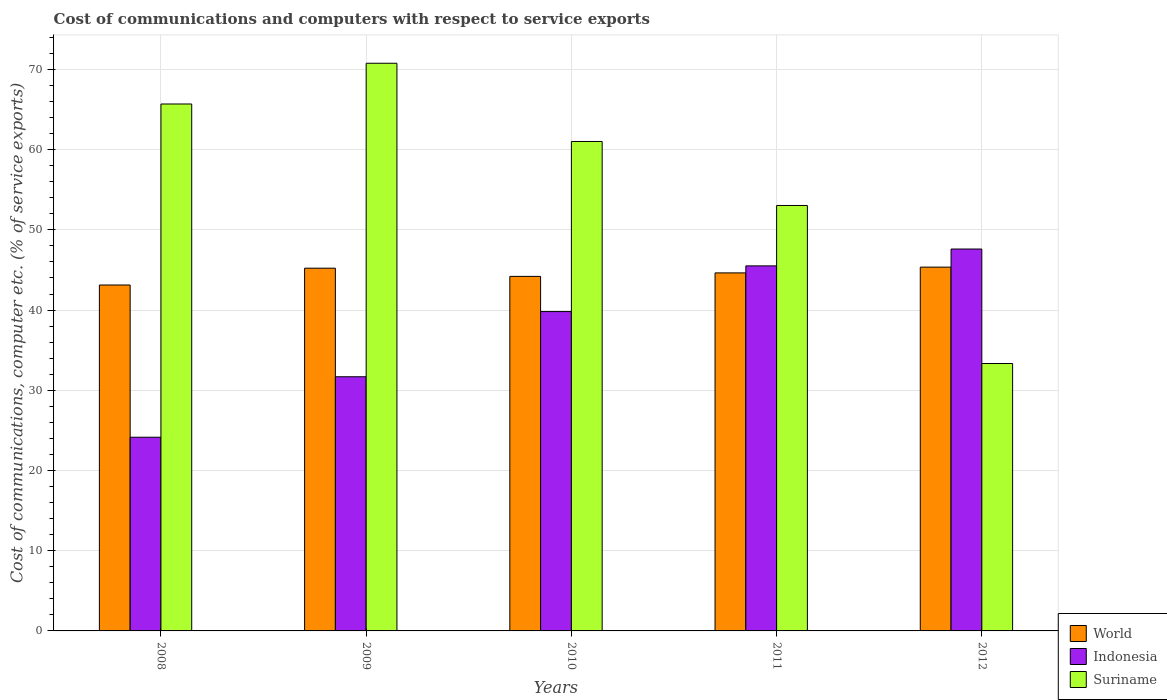Are the number of bars per tick equal to the number of legend labels?
Your response must be concise. Yes. How many bars are there on the 3rd tick from the left?
Offer a terse response. 3. In how many cases, is the number of bars for a given year not equal to the number of legend labels?
Make the answer very short. 0. What is the cost of communications and computers in World in 2010?
Offer a terse response. 44.2. Across all years, what is the maximum cost of communications and computers in Suriname?
Give a very brief answer. 70.77. Across all years, what is the minimum cost of communications and computers in Indonesia?
Give a very brief answer. 24.15. In which year was the cost of communications and computers in World maximum?
Make the answer very short. 2012. What is the total cost of communications and computers in World in the graph?
Your answer should be compact. 222.54. What is the difference between the cost of communications and computers in World in 2008 and that in 2011?
Provide a succinct answer. -1.51. What is the difference between the cost of communications and computers in Indonesia in 2008 and the cost of communications and computers in World in 2009?
Provide a succinct answer. -21.08. What is the average cost of communications and computers in Indonesia per year?
Offer a very short reply. 37.75. In the year 2011, what is the difference between the cost of communications and computers in Suriname and cost of communications and computers in World?
Give a very brief answer. 8.4. In how many years, is the cost of communications and computers in Suriname greater than 36 %?
Make the answer very short. 4. What is the ratio of the cost of communications and computers in Suriname in 2010 to that in 2011?
Keep it short and to the point. 1.15. Is the cost of communications and computers in Indonesia in 2008 less than that in 2010?
Keep it short and to the point. Yes. Is the difference between the cost of communications and computers in Suriname in 2008 and 2012 greater than the difference between the cost of communications and computers in World in 2008 and 2012?
Offer a terse response. Yes. What is the difference between the highest and the second highest cost of communications and computers in Indonesia?
Offer a very short reply. 2.1. What is the difference between the highest and the lowest cost of communications and computers in Indonesia?
Ensure brevity in your answer.  23.46. Is the sum of the cost of communications and computers in World in 2008 and 2011 greater than the maximum cost of communications and computers in Indonesia across all years?
Provide a short and direct response. Yes. What does the 1st bar from the left in 2009 represents?
Ensure brevity in your answer.  World. What does the 1st bar from the right in 2011 represents?
Your answer should be very brief. Suriname. How many years are there in the graph?
Offer a terse response. 5. Does the graph contain any zero values?
Provide a short and direct response. No. Does the graph contain grids?
Provide a short and direct response. Yes. How many legend labels are there?
Keep it short and to the point. 3. How are the legend labels stacked?
Offer a very short reply. Vertical. What is the title of the graph?
Make the answer very short. Cost of communications and computers with respect to service exports. Does "West Bank and Gaza" appear as one of the legend labels in the graph?
Provide a short and direct response. No. What is the label or title of the Y-axis?
Offer a very short reply. Cost of communications, computer etc. (% of service exports). What is the Cost of communications, computer etc. (% of service exports) of World in 2008?
Your response must be concise. 43.13. What is the Cost of communications, computer etc. (% of service exports) of Indonesia in 2008?
Provide a short and direct response. 24.15. What is the Cost of communications, computer etc. (% of service exports) in Suriname in 2008?
Provide a short and direct response. 65.69. What is the Cost of communications, computer etc. (% of service exports) in World in 2009?
Make the answer very short. 45.22. What is the Cost of communications, computer etc. (% of service exports) in Indonesia in 2009?
Your answer should be compact. 31.69. What is the Cost of communications, computer etc. (% of service exports) of Suriname in 2009?
Keep it short and to the point. 70.77. What is the Cost of communications, computer etc. (% of service exports) of World in 2010?
Offer a very short reply. 44.2. What is the Cost of communications, computer etc. (% of service exports) of Indonesia in 2010?
Keep it short and to the point. 39.81. What is the Cost of communications, computer etc. (% of service exports) in Suriname in 2010?
Make the answer very short. 61.02. What is the Cost of communications, computer etc. (% of service exports) in World in 2011?
Your answer should be compact. 44.64. What is the Cost of communications, computer etc. (% of service exports) in Indonesia in 2011?
Provide a short and direct response. 45.51. What is the Cost of communications, computer etc. (% of service exports) in Suriname in 2011?
Make the answer very short. 53.04. What is the Cost of communications, computer etc. (% of service exports) of World in 2012?
Your response must be concise. 45.35. What is the Cost of communications, computer etc. (% of service exports) of Indonesia in 2012?
Provide a short and direct response. 47.61. What is the Cost of communications, computer etc. (% of service exports) of Suriname in 2012?
Provide a succinct answer. 33.34. Across all years, what is the maximum Cost of communications, computer etc. (% of service exports) in World?
Your response must be concise. 45.35. Across all years, what is the maximum Cost of communications, computer etc. (% of service exports) of Indonesia?
Your response must be concise. 47.61. Across all years, what is the maximum Cost of communications, computer etc. (% of service exports) in Suriname?
Provide a succinct answer. 70.77. Across all years, what is the minimum Cost of communications, computer etc. (% of service exports) in World?
Offer a very short reply. 43.13. Across all years, what is the minimum Cost of communications, computer etc. (% of service exports) in Indonesia?
Your answer should be very brief. 24.15. Across all years, what is the minimum Cost of communications, computer etc. (% of service exports) of Suriname?
Make the answer very short. 33.34. What is the total Cost of communications, computer etc. (% of service exports) of World in the graph?
Offer a terse response. 222.54. What is the total Cost of communications, computer etc. (% of service exports) in Indonesia in the graph?
Provide a succinct answer. 188.77. What is the total Cost of communications, computer etc. (% of service exports) of Suriname in the graph?
Your answer should be compact. 283.86. What is the difference between the Cost of communications, computer etc. (% of service exports) in World in 2008 and that in 2009?
Your response must be concise. -2.1. What is the difference between the Cost of communications, computer etc. (% of service exports) in Indonesia in 2008 and that in 2009?
Your response must be concise. -7.54. What is the difference between the Cost of communications, computer etc. (% of service exports) of Suriname in 2008 and that in 2009?
Your response must be concise. -5.08. What is the difference between the Cost of communications, computer etc. (% of service exports) in World in 2008 and that in 2010?
Provide a succinct answer. -1.07. What is the difference between the Cost of communications, computer etc. (% of service exports) in Indonesia in 2008 and that in 2010?
Your answer should be compact. -15.67. What is the difference between the Cost of communications, computer etc. (% of service exports) of Suriname in 2008 and that in 2010?
Your answer should be compact. 4.67. What is the difference between the Cost of communications, computer etc. (% of service exports) of World in 2008 and that in 2011?
Your answer should be compact. -1.51. What is the difference between the Cost of communications, computer etc. (% of service exports) in Indonesia in 2008 and that in 2011?
Offer a very short reply. -21.36. What is the difference between the Cost of communications, computer etc. (% of service exports) in Suriname in 2008 and that in 2011?
Ensure brevity in your answer.  12.65. What is the difference between the Cost of communications, computer etc. (% of service exports) of World in 2008 and that in 2012?
Provide a succinct answer. -2.23. What is the difference between the Cost of communications, computer etc. (% of service exports) of Indonesia in 2008 and that in 2012?
Offer a terse response. -23.46. What is the difference between the Cost of communications, computer etc. (% of service exports) of Suriname in 2008 and that in 2012?
Offer a terse response. 32.36. What is the difference between the Cost of communications, computer etc. (% of service exports) of World in 2009 and that in 2010?
Your answer should be very brief. 1.02. What is the difference between the Cost of communications, computer etc. (% of service exports) in Indonesia in 2009 and that in 2010?
Your response must be concise. -8.13. What is the difference between the Cost of communications, computer etc. (% of service exports) of Suriname in 2009 and that in 2010?
Give a very brief answer. 9.75. What is the difference between the Cost of communications, computer etc. (% of service exports) of World in 2009 and that in 2011?
Provide a short and direct response. 0.59. What is the difference between the Cost of communications, computer etc. (% of service exports) of Indonesia in 2009 and that in 2011?
Your answer should be very brief. -13.82. What is the difference between the Cost of communications, computer etc. (% of service exports) in Suriname in 2009 and that in 2011?
Keep it short and to the point. 17.73. What is the difference between the Cost of communications, computer etc. (% of service exports) of World in 2009 and that in 2012?
Your response must be concise. -0.13. What is the difference between the Cost of communications, computer etc. (% of service exports) of Indonesia in 2009 and that in 2012?
Provide a short and direct response. -15.92. What is the difference between the Cost of communications, computer etc. (% of service exports) in Suriname in 2009 and that in 2012?
Offer a very short reply. 37.43. What is the difference between the Cost of communications, computer etc. (% of service exports) of World in 2010 and that in 2011?
Offer a terse response. -0.44. What is the difference between the Cost of communications, computer etc. (% of service exports) of Indonesia in 2010 and that in 2011?
Your answer should be compact. -5.69. What is the difference between the Cost of communications, computer etc. (% of service exports) of Suriname in 2010 and that in 2011?
Your response must be concise. 7.98. What is the difference between the Cost of communications, computer etc. (% of service exports) of World in 2010 and that in 2012?
Your answer should be compact. -1.15. What is the difference between the Cost of communications, computer etc. (% of service exports) in Indonesia in 2010 and that in 2012?
Give a very brief answer. -7.8. What is the difference between the Cost of communications, computer etc. (% of service exports) in Suriname in 2010 and that in 2012?
Give a very brief answer. 27.68. What is the difference between the Cost of communications, computer etc. (% of service exports) in World in 2011 and that in 2012?
Provide a short and direct response. -0.72. What is the difference between the Cost of communications, computer etc. (% of service exports) in Indonesia in 2011 and that in 2012?
Provide a short and direct response. -2.1. What is the difference between the Cost of communications, computer etc. (% of service exports) of Suriname in 2011 and that in 2012?
Your answer should be very brief. 19.7. What is the difference between the Cost of communications, computer etc. (% of service exports) in World in 2008 and the Cost of communications, computer etc. (% of service exports) in Indonesia in 2009?
Give a very brief answer. 11.44. What is the difference between the Cost of communications, computer etc. (% of service exports) in World in 2008 and the Cost of communications, computer etc. (% of service exports) in Suriname in 2009?
Offer a terse response. -27.64. What is the difference between the Cost of communications, computer etc. (% of service exports) of Indonesia in 2008 and the Cost of communications, computer etc. (% of service exports) of Suriname in 2009?
Offer a very short reply. -46.62. What is the difference between the Cost of communications, computer etc. (% of service exports) of World in 2008 and the Cost of communications, computer etc. (% of service exports) of Indonesia in 2010?
Offer a very short reply. 3.31. What is the difference between the Cost of communications, computer etc. (% of service exports) of World in 2008 and the Cost of communications, computer etc. (% of service exports) of Suriname in 2010?
Ensure brevity in your answer.  -17.89. What is the difference between the Cost of communications, computer etc. (% of service exports) of Indonesia in 2008 and the Cost of communications, computer etc. (% of service exports) of Suriname in 2010?
Your answer should be compact. -36.87. What is the difference between the Cost of communications, computer etc. (% of service exports) of World in 2008 and the Cost of communications, computer etc. (% of service exports) of Indonesia in 2011?
Ensure brevity in your answer.  -2.38. What is the difference between the Cost of communications, computer etc. (% of service exports) of World in 2008 and the Cost of communications, computer etc. (% of service exports) of Suriname in 2011?
Your answer should be compact. -9.91. What is the difference between the Cost of communications, computer etc. (% of service exports) in Indonesia in 2008 and the Cost of communications, computer etc. (% of service exports) in Suriname in 2011?
Provide a short and direct response. -28.89. What is the difference between the Cost of communications, computer etc. (% of service exports) of World in 2008 and the Cost of communications, computer etc. (% of service exports) of Indonesia in 2012?
Offer a very short reply. -4.49. What is the difference between the Cost of communications, computer etc. (% of service exports) in World in 2008 and the Cost of communications, computer etc. (% of service exports) in Suriname in 2012?
Your response must be concise. 9.79. What is the difference between the Cost of communications, computer etc. (% of service exports) of Indonesia in 2008 and the Cost of communications, computer etc. (% of service exports) of Suriname in 2012?
Ensure brevity in your answer.  -9.19. What is the difference between the Cost of communications, computer etc. (% of service exports) in World in 2009 and the Cost of communications, computer etc. (% of service exports) in Indonesia in 2010?
Your answer should be compact. 5.41. What is the difference between the Cost of communications, computer etc. (% of service exports) in World in 2009 and the Cost of communications, computer etc. (% of service exports) in Suriname in 2010?
Ensure brevity in your answer.  -15.8. What is the difference between the Cost of communications, computer etc. (% of service exports) of Indonesia in 2009 and the Cost of communications, computer etc. (% of service exports) of Suriname in 2010?
Give a very brief answer. -29.33. What is the difference between the Cost of communications, computer etc. (% of service exports) in World in 2009 and the Cost of communications, computer etc. (% of service exports) in Indonesia in 2011?
Your answer should be compact. -0.29. What is the difference between the Cost of communications, computer etc. (% of service exports) of World in 2009 and the Cost of communications, computer etc. (% of service exports) of Suriname in 2011?
Your answer should be very brief. -7.82. What is the difference between the Cost of communications, computer etc. (% of service exports) of Indonesia in 2009 and the Cost of communications, computer etc. (% of service exports) of Suriname in 2011?
Give a very brief answer. -21.35. What is the difference between the Cost of communications, computer etc. (% of service exports) in World in 2009 and the Cost of communications, computer etc. (% of service exports) in Indonesia in 2012?
Offer a terse response. -2.39. What is the difference between the Cost of communications, computer etc. (% of service exports) in World in 2009 and the Cost of communications, computer etc. (% of service exports) in Suriname in 2012?
Provide a succinct answer. 11.88. What is the difference between the Cost of communications, computer etc. (% of service exports) in Indonesia in 2009 and the Cost of communications, computer etc. (% of service exports) in Suriname in 2012?
Make the answer very short. -1.65. What is the difference between the Cost of communications, computer etc. (% of service exports) of World in 2010 and the Cost of communications, computer etc. (% of service exports) of Indonesia in 2011?
Your response must be concise. -1.31. What is the difference between the Cost of communications, computer etc. (% of service exports) of World in 2010 and the Cost of communications, computer etc. (% of service exports) of Suriname in 2011?
Provide a short and direct response. -8.84. What is the difference between the Cost of communications, computer etc. (% of service exports) of Indonesia in 2010 and the Cost of communications, computer etc. (% of service exports) of Suriname in 2011?
Ensure brevity in your answer.  -13.23. What is the difference between the Cost of communications, computer etc. (% of service exports) of World in 2010 and the Cost of communications, computer etc. (% of service exports) of Indonesia in 2012?
Provide a short and direct response. -3.41. What is the difference between the Cost of communications, computer etc. (% of service exports) of World in 2010 and the Cost of communications, computer etc. (% of service exports) of Suriname in 2012?
Provide a short and direct response. 10.86. What is the difference between the Cost of communications, computer etc. (% of service exports) in Indonesia in 2010 and the Cost of communications, computer etc. (% of service exports) in Suriname in 2012?
Offer a very short reply. 6.48. What is the difference between the Cost of communications, computer etc. (% of service exports) in World in 2011 and the Cost of communications, computer etc. (% of service exports) in Indonesia in 2012?
Ensure brevity in your answer.  -2.98. What is the difference between the Cost of communications, computer etc. (% of service exports) in World in 2011 and the Cost of communications, computer etc. (% of service exports) in Suriname in 2012?
Make the answer very short. 11.3. What is the difference between the Cost of communications, computer etc. (% of service exports) in Indonesia in 2011 and the Cost of communications, computer etc. (% of service exports) in Suriname in 2012?
Ensure brevity in your answer.  12.17. What is the average Cost of communications, computer etc. (% of service exports) in World per year?
Offer a very short reply. 44.51. What is the average Cost of communications, computer etc. (% of service exports) in Indonesia per year?
Keep it short and to the point. 37.75. What is the average Cost of communications, computer etc. (% of service exports) of Suriname per year?
Your answer should be compact. 56.77. In the year 2008, what is the difference between the Cost of communications, computer etc. (% of service exports) of World and Cost of communications, computer etc. (% of service exports) of Indonesia?
Your answer should be compact. 18.98. In the year 2008, what is the difference between the Cost of communications, computer etc. (% of service exports) of World and Cost of communications, computer etc. (% of service exports) of Suriname?
Provide a succinct answer. -22.57. In the year 2008, what is the difference between the Cost of communications, computer etc. (% of service exports) in Indonesia and Cost of communications, computer etc. (% of service exports) in Suriname?
Your response must be concise. -41.55. In the year 2009, what is the difference between the Cost of communications, computer etc. (% of service exports) in World and Cost of communications, computer etc. (% of service exports) in Indonesia?
Ensure brevity in your answer.  13.54. In the year 2009, what is the difference between the Cost of communications, computer etc. (% of service exports) of World and Cost of communications, computer etc. (% of service exports) of Suriname?
Your answer should be compact. -25.55. In the year 2009, what is the difference between the Cost of communications, computer etc. (% of service exports) in Indonesia and Cost of communications, computer etc. (% of service exports) in Suriname?
Ensure brevity in your answer.  -39.08. In the year 2010, what is the difference between the Cost of communications, computer etc. (% of service exports) in World and Cost of communications, computer etc. (% of service exports) in Indonesia?
Offer a very short reply. 4.39. In the year 2010, what is the difference between the Cost of communications, computer etc. (% of service exports) in World and Cost of communications, computer etc. (% of service exports) in Suriname?
Your answer should be very brief. -16.82. In the year 2010, what is the difference between the Cost of communications, computer etc. (% of service exports) of Indonesia and Cost of communications, computer etc. (% of service exports) of Suriname?
Keep it short and to the point. -21.2. In the year 2011, what is the difference between the Cost of communications, computer etc. (% of service exports) in World and Cost of communications, computer etc. (% of service exports) in Indonesia?
Your response must be concise. -0.87. In the year 2011, what is the difference between the Cost of communications, computer etc. (% of service exports) of World and Cost of communications, computer etc. (% of service exports) of Suriname?
Make the answer very short. -8.4. In the year 2011, what is the difference between the Cost of communications, computer etc. (% of service exports) in Indonesia and Cost of communications, computer etc. (% of service exports) in Suriname?
Your answer should be very brief. -7.53. In the year 2012, what is the difference between the Cost of communications, computer etc. (% of service exports) in World and Cost of communications, computer etc. (% of service exports) in Indonesia?
Offer a terse response. -2.26. In the year 2012, what is the difference between the Cost of communications, computer etc. (% of service exports) in World and Cost of communications, computer etc. (% of service exports) in Suriname?
Offer a very short reply. 12.02. In the year 2012, what is the difference between the Cost of communications, computer etc. (% of service exports) in Indonesia and Cost of communications, computer etc. (% of service exports) in Suriname?
Provide a succinct answer. 14.27. What is the ratio of the Cost of communications, computer etc. (% of service exports) in World in 2008 to that in 2009?
Your answer should be very brief. 0.95. What is the ratio of the Cost of communications, computer etc. (% of service exports) in Indonesia in 2008 to that in 2009?
Provide a succinct answer. 0.76. What is the ratio of the Cost of communications, computer etc. (% of service exports) in Suriname in 2008 to that in 2009?
Make the answer very short. 0.93. What is the ratio of the Cost of communications, computer etc. (% of service exports) of World in 2008 to that in 2010?
Offer a very short reply. 0.98. What is the ratio of the Cost of communications, computer etc. (% of service exports) of Indonesia in 2008 to that in 2010?
Make the answer very short. 0.61. What is the ratio of the Cost of communications, computer etc. (% of service exports) of Suriname in 2008 to that in 2010?
Your answer should be very brief. 1.08. What is the ratio of the Cost of communications, computer etc. (% of service exports) in World in 2008 to that in 2011?
Make the answer very short. 0.97. What is the ratio of the Cost of communications, computer etc. (% of service exports) in Indonesia in 2008 to that in 2011?
Offer a very short reply. 0.53. What is the ratio of the Cost of communications, computer etc. (% of service exports) of Suriname in 2008 to that in 2011?
Offer a very short reply. 1.24. What is the ratio of the Cost of communications, computer etc. (% of service exports) in World in 2008 to that in 2012?
Provide a succinct answer. 0.95. What is the ratio of the Cost of communications, computer etc. (% of service exports) in Indonesia in 2008 to that in 2012?
Ensure brevity in your answer.  0.51. What is the ratio of the Cost of communications, computer etc. (% of service exports) of Suriname in 2008 to that in 2012?
Make the answer very short. 1.97. What is the ratio of the Cost of communications, computer etc. (% of service exports) in World in 2009 to that in 2010?
Keep it short and to the point. 1.02. What is the ratio of the Cost of communications, computer etc. (% of service exports) of Indonesia in 2009 to that in 2010?
Make the answer very short. 0.8. What is the ratio of the Cost of communications, computer etc. (% of service exports) in Suriname in 2009 to that in 2010?
Offer a terse response. 1.16. What is the ratio of the Cost of communications, computer etc. (% of service exports) of World in 2009 to that in 2011?
Ensure brevity in your answer.  1.01. What is the ratio of the Cost of communications, computer etc. (% of service exports) in Indonesia in 2009 to that in 2011?
Keep it short and to the point. 0.7. What is the ratio of the Cost of communications, computer etc. (% of service exports) in Suriname in 2009 to that in 2011?
Your response must be concise. 1.33. What is the ratio of the Cost of communications, computer etc. (% of service exports) of World in 2009 to that in 2012?
Make the answer very short. 1. What is the ratio of the Cost of communications, computer etc. (% of service exports) in Indonesia in 2009 to that in 2012?
Give a very brief answer. 0.67. What is the ratio of the Cost of communications, computer etc. (% of service exports) of Suriname in 2009 to that in 2012?
Offer a very short reply. 2.12. What is the ratio of the Cost of communications, computer etc. (% of service exports) of World in 2010 to that in 2011?
Make the answer very short. 0.99. What is the ratio of the Cost of communications, computer etc. (% of service exports) of Indonesia in 2010 to that in 2011?
Provide a short and direct response. 0.87. What is the ratio of the Cost of communications, computer etc. (% of service exports) in Suriname in 2010 to that in 2011?
Give a very brief answer. 1.15. What is the ratio of the Cost of communications, computer etc. (% of service exports) in World in 2010 to that in 2012?
Provide a succinct answer. 0.97. What is the ratio of the Cost of communications, computer etc. (% of service exports) of Indonesia in 2010 to that in 2012?
Your answer should be very brief. 0.84. What is the ratio of the Cost of communications, computer etc. (% of service exports) of Suriname in 2010 to that in 2012?
Give a very brief answer. 1.83. What is the ratio of the Cost of communications, computer etc. (% of service exports) in World in 2011 to that in 2012?
Provide a succinct answer. 0.98. What is the ratio of the Cost of communications, computer etc. (% of service exports) in Indonesia in 2011 to that in 2012?
Keep it short and to the point. 0.96. What is the ratio of the Cost of communications, computer etc. (% of service exports) of Suriname in 2011 to that in 2012?
Your answer should be compact. 1.59. What is the difference between the highest and the second highest Cost of communications, computer etc. (% of service exports) of World?
Your answer should be very brief. 0.13. What is the difference between the highest and the second highest Cost of communications, computer etc. (% of service exports) in Indonesia?
Ensure brevity in your answer.  2.1. What is the difference between the highest and the second highest Cost of communications, computer etc. (% of service exports) of Suriname?
Your answer should be very brief. 5.08. What is the difference between the highest and the lowest Cost of communications, computer etc. (% of service exports) in World?
Offer a terse response. 2.23. What is the difference between the highest and the lowest Cost of communications, computer etc. (% of service exports) in Indonesia?
Offer a very short reply. 23.46. What is the difference between the highest and the lowest Cost of communications, computer etc. (% of service exports) in Suriname?
Your response must be concise. 37.43. 